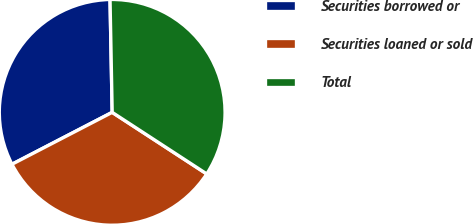Convert chart. <chart><loc_0><loc_0><loc_500><loc_500><pie_chart><fcel>Securities borrowed or<fcel>Securities loaned or sold<fcel>Total<nl><fcel>32.3%<fcel>33.2%<fcel>34.49%<nl></chart> 